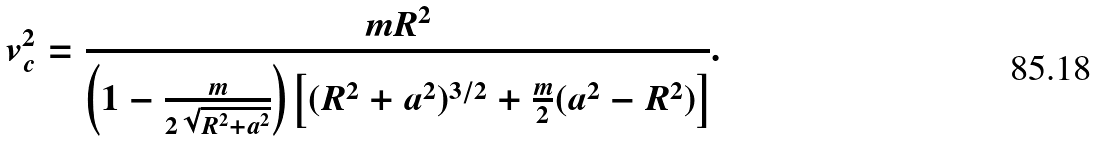Convert formula to latex. <formula><loc_0><loc_0><loc_500><loc_500>v _ { c } ^ { 2 } = \frac { m R ^ { 2 } } { \left ( 1 - \frac { m } { 2 \sqrt { R ^ { 2 } + a ^ { 2 } } } \right ) \left [ ( R ^ { 2 } + a ^ { 2 } ) ^ { 3 / 2 } + \frac { m } { 2 } ( a ^ { 2 } - R ^ { 2 } ) \right ] } .</formula> 